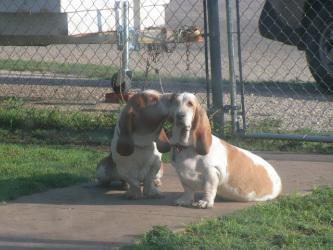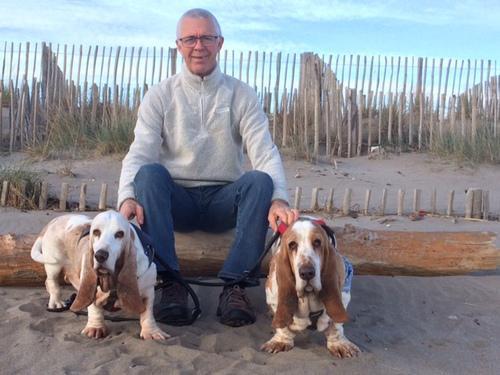The first image is the image on the left, the second image is the image on the right. Evaluate the accuracy of this statement regarding the images: "One image contains two basset hounds and no humans, and the other image includes at least one person with multiple basset hounds on leashes.". Is it true? Answer yes or no. Yes. The first image is the image on the left, the second image is the image on the right. For the images shown, is this caption "One picture has atleast 2 dogs and a person." true? Answer yes or no. Yes. 